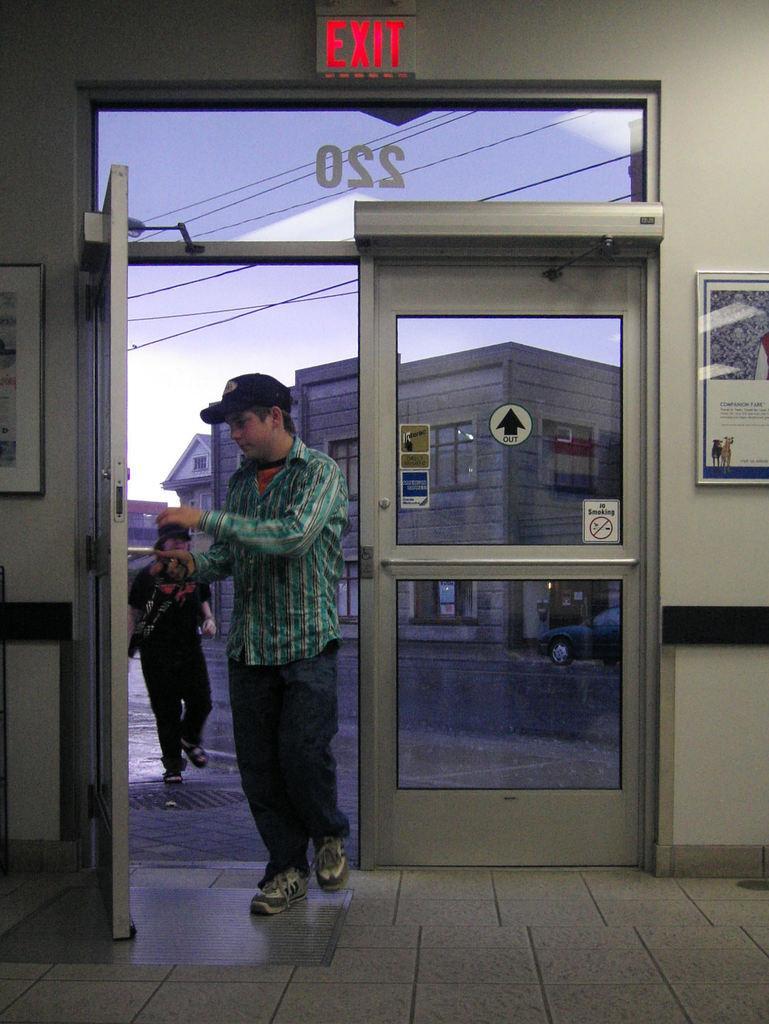How would you summarize this image in a sentence or two? In this picture there is a person wearing green color shirt and a black color cap on his head. I can observe doors. There is a road. On the right side I can observe photo frame fixed to the wall. In the background there are buildings and a sky. 